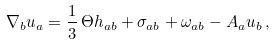Convert formula to latex. <formula><loc_0><loc_0><loc_500><loc_500>\nabla _ { b } u _ { a } = { \frac { 1 } { 3 } } \, \Theta h _ { a b } + \sigma _ { a b } + \omega _ { a b } - A _ { a } u _ { b } \, ,</formula> 